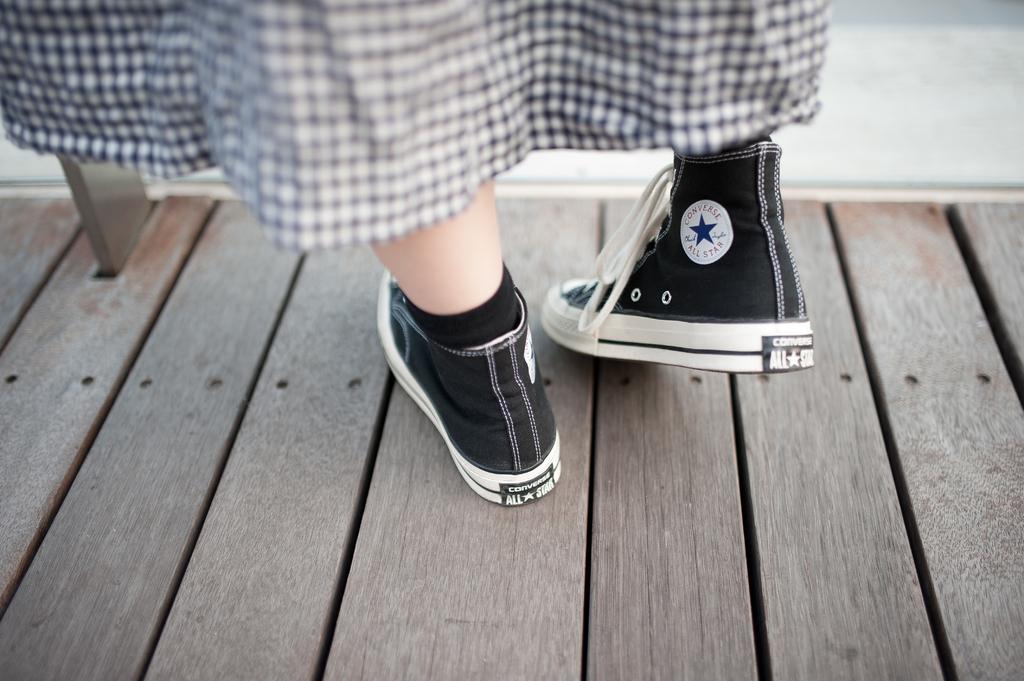Can you describe this image briefly? In this picture we can see a person legs wearing shoes and a dress. At the bottom portion of the picture we can see the wooden surface. 